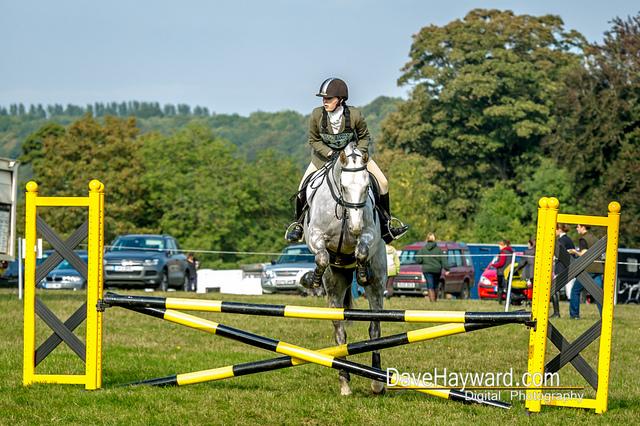What is the black strip across the horse's face?
Give a very brief answer. Bridle. How do you call man jumping on a horse?
Write a very short answer. Jockey. Are they in a competition?
Keep it brief. Yes. 